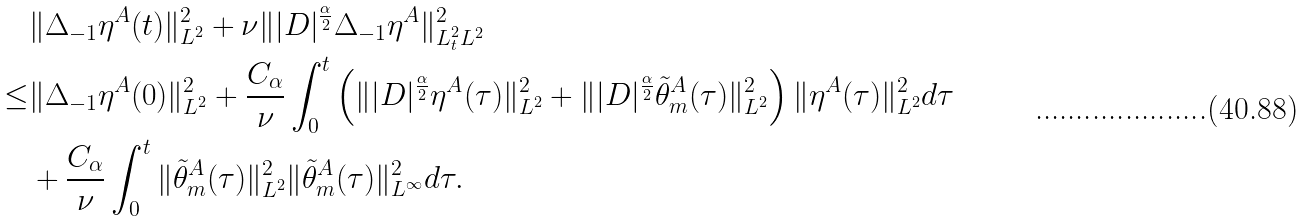Convert formula to latex. <formula><loc_0><loc_0><loc_500><loc_500>& \| \Delta _ { - 1 } \eta ^ { A } ( t ) \| ^ { 2 } _ { L ^ { 2 } } + \nu \| | D | ^ { \frac { \alpha } { 2 } } \Delta _ { - 1 } \eta ^ { A } \| _ { L ^ { 2 } _ { t } L ^ { 2 } } ^ { 2 } \\ \leq & \| \Delta _ { - 1 } \eta ^ { A } ( 0 ) \| ^ { 2 } _ { L ^ { 2 } } + \frac { C _ { \alpha } } { \nu } \int _ { 0 } ^ { t } \left ( \| | D | ^ { \frac { \alpha } { 2 } } \eta ^ { A } ( \tau ) \| ^ { 2 } _ { L ^ { 2 } } + \| | D | ^ { \frac { \alpha } { 2 } } \tilde { \theta } ^ { A } _ { m } ( \tau ) \| _ { L ^ { 2 } } ^ { 2 } \right ) \| \eta ^ { A } ( \tau ) \| ^ { 2 } _ { L ^ { 2 } } d \tau \\ & + \frac { C _ { \alpha } } { \nu } \int _ { 0 } ^ { t } \| \tilde { \theta } ^ { A } _ { m } ( \tau ) \| _ { L ^ { 2 } } ^ { 2 } \| \tilde { \theta } ^ { A } _ { m } ( \tau ) \| _ { L ^ { \infty } } ^ { 2 } d \tau .</formula> 